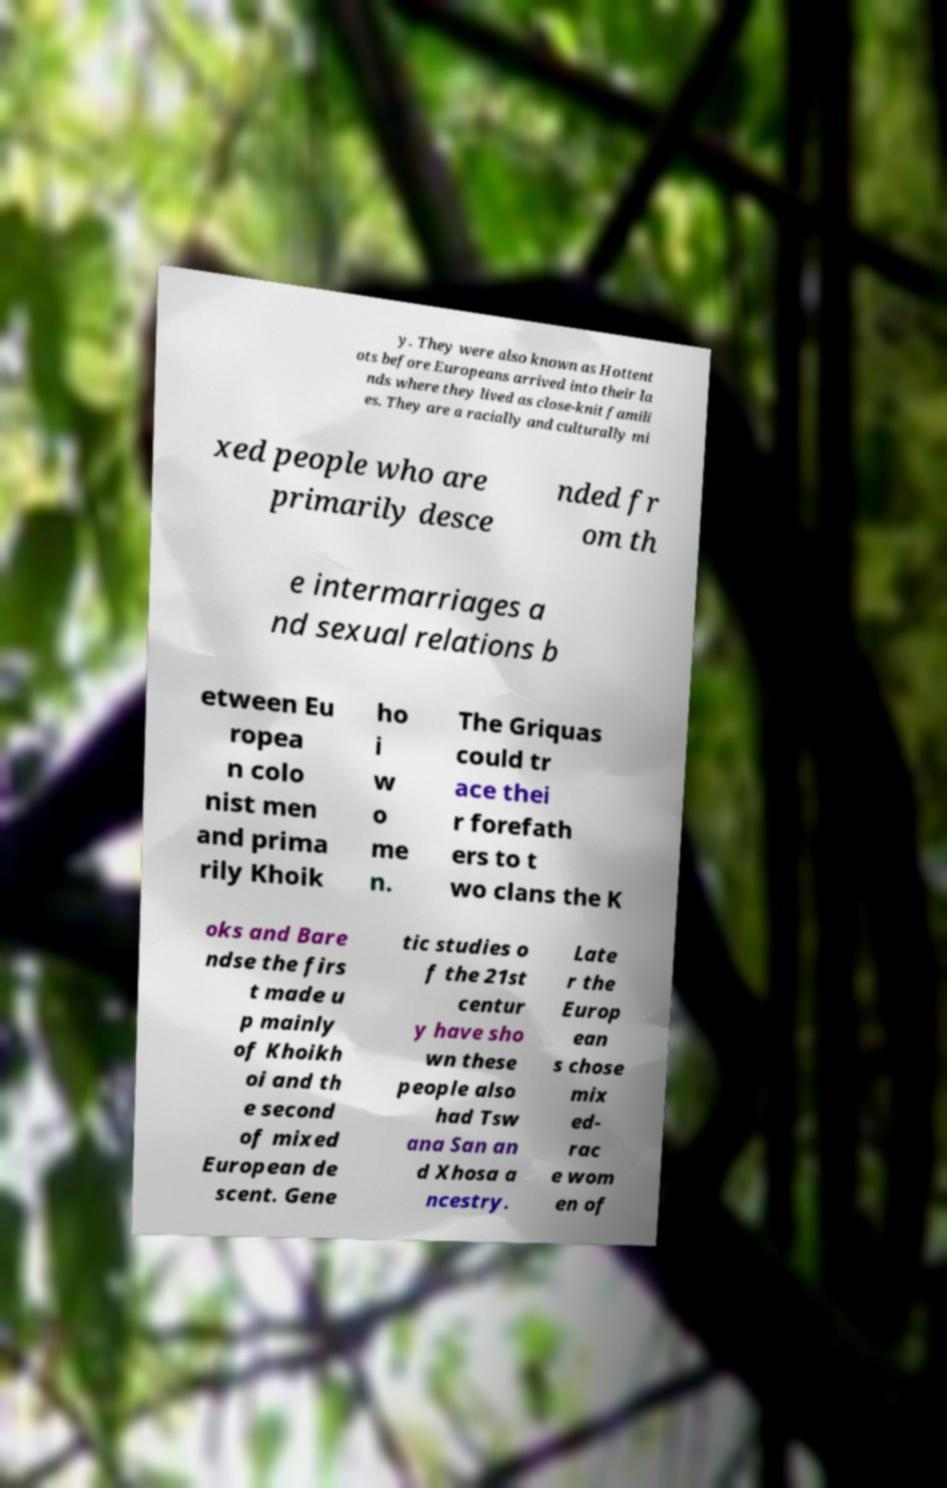Can you accurately transcribe the text from the provided image for me? y. They were also known as Hottent ots before Europeans arrived into their la nds where they lived as close-knit famili es. They are a racially and culturally mi xed people who are primarily desce nded fr om th e intermarriages a nd sexual relations b etween Eu ropea n colo nist men and prima rily Khoik ho i w o me n. The Griquas could tr ace thei r forefath ers to t wo clans the K oks and Bare ndse the firs t made u p mainly of Khoikh oi and th e second of mixed European de scent. Gene tic studies o f the 21st centur y have sho wn these people also had Tsw ana San an d Xhosa a ncestry. Late r the Europ ean s chose mix ed- rac e wom en of 